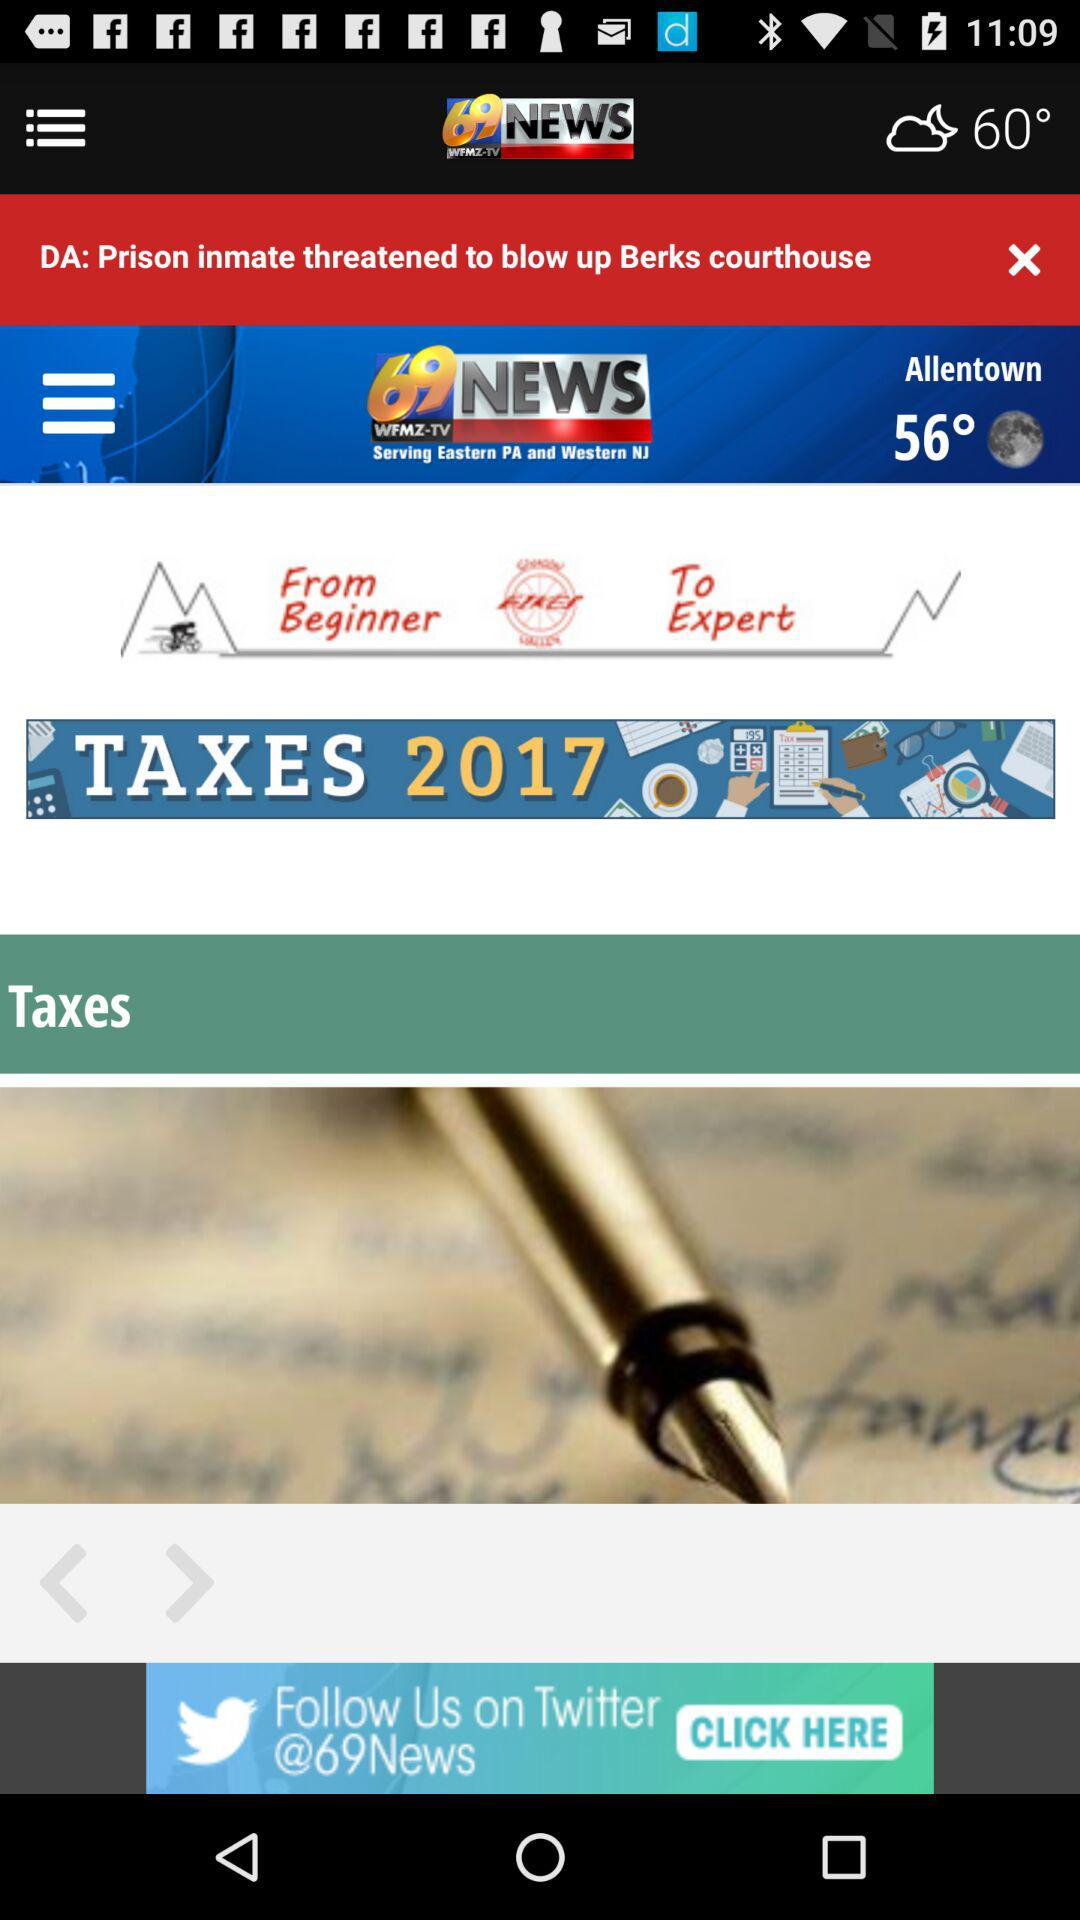What is the version of this application?
When the provided information is insufficient, respond with <no answer>. <no answer> 